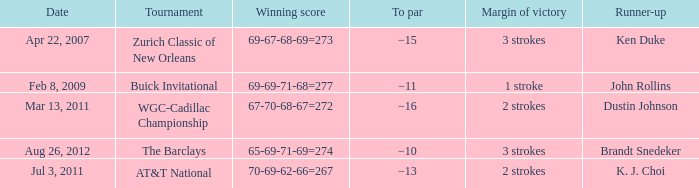What is the date that has a winning score of 67-70-68-67=272? Mar 13, 2011. 